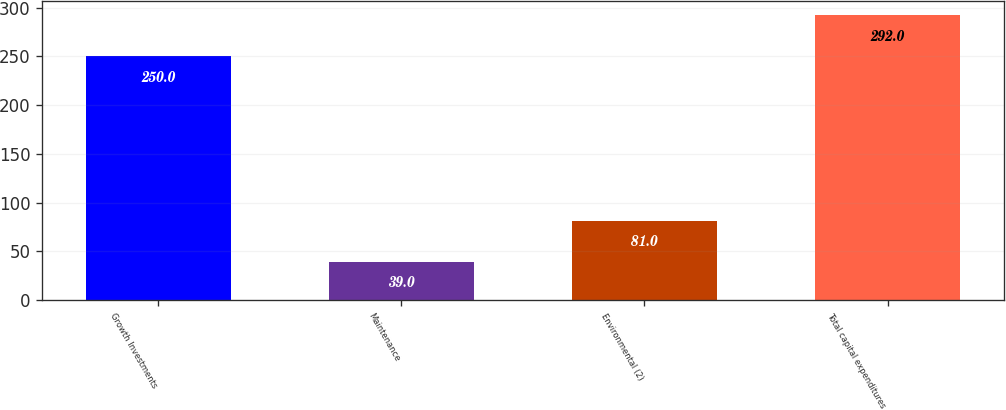<chart> <loc_0><loc_0><loc_500><loc_500><bar_chart><fcel>Growth Investments<fcel>Maintenance<fcel>Environmental (2)<fcel>Total capital expenditures<nl><fcel>250<fcel>39<fcel>81<fcel>292<nl></chart> 